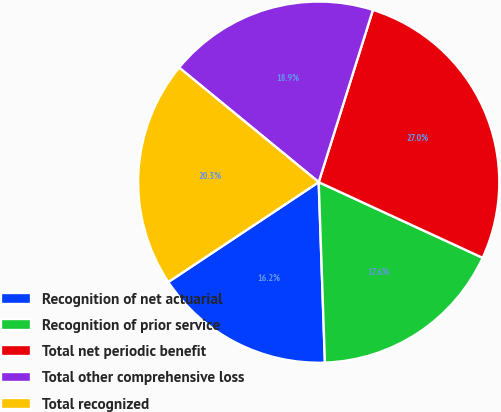<chart> <loc_0><loc_0><loc_500><loc_500><pie_chart><fcel>Recognition of net actuarial<fcel>Recognition of prior service<fcel>Total net periodic benefit<fcel>Total other comprehensive loss<fcel>Total recognized<nl><fcel>16.22%<fcel>17.57%<fcel>27.03%<fcel>18.92%<fcel>20.27%<nl></chart> 